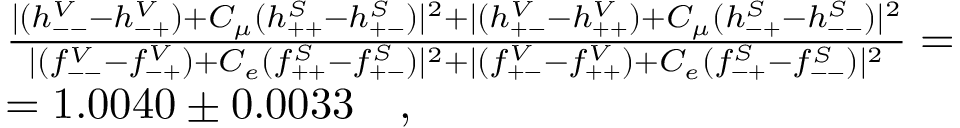<formula> <loc_0><loc_0><loc_500><loc_500>\begin{array} { r l & { { \frac { | ( h _ { - - } ^ { V } - h _ { - + } ^ { V } ) + C _ { \mu } ( h _ { + + } ^ { S } - h _ { + - } ^ { S } ) | ^ { 2 } + | ( h _ { + - } ^ { V } - h _ { + + } ^ { V } ) + C _ { \mu } ( h _ { - + } ^ { S } - h _ { - - } ^ { S } ) | ^ { 2 } } { | ( f _ { - - } ^ { V } - f _ { - + } ^ { V } ) + C _ { e } ( f _ { + + } ^ { S } - f _ { + - } ^ { S } ) | ^ { 2 } + | ( f _ { + - } ^ { V } - f _ { + + } ^ { V } ) + C _ { e } ( f _ { - + } ^ { S } - f _ { - - } ^ { S } ) | ^ { 2 } } = } } & { = 1 . 0 0 4 0 \pm 0 . 0 0 3 3 \quad , } \end{array}</formula> 